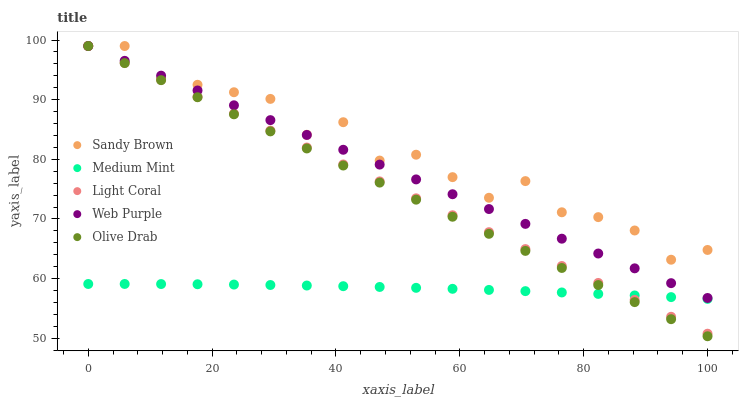Does Medium Mint have the minimum area under the curve?
Answer yes or no. Yes. Does Sandy Brown have the maximum area under the curve?
Answer yes or no. Yes. Does Light Coral have the minimum area under the curve?
Answer yes or no. No. Does Light Coral have the maximum area under the curve?
Answer yes or no. No. Is Light Coral the smoothest?
Answer yes or no. Yes. Is Sandy Brown the roughest?
Answer yes or no. Yes. Is Web Purple the smoothest?
Answer yes or no. No. Is Web Purple the roughest?
Answer yes or no. No. Does Olive Drab have the lowest value?
Answer yes or no. Yes. Does Light Coral have the lowest value?
Answer yes or no. No. Does Olive Drab have the highest value?
Answer yes or no. Yes. Is Medium Mint less than Sandy Brown?
Answer yes or no. Yes. Is Sandy Brown greater than Medium Mint?
Answer yes or no. Yes. Does Olive Drab intersect Medium Mint?
Answer yes or no. Yes. Is Olive Drab less than Medium Mint?
Answer yes or no. No. Is Olive Drab greater than Medium Mint?
Answer yes or no. No. Does Medium Mint intersect Sandy Brown?
Answer yes or no. No. 